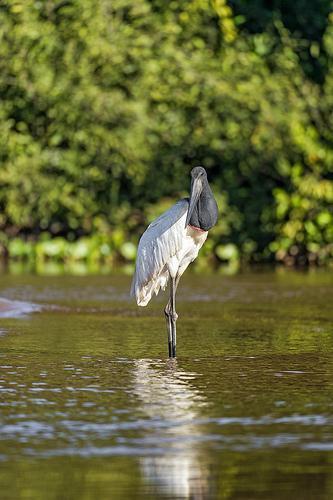How many birds are shown?
Give a very brief answer. 1. 